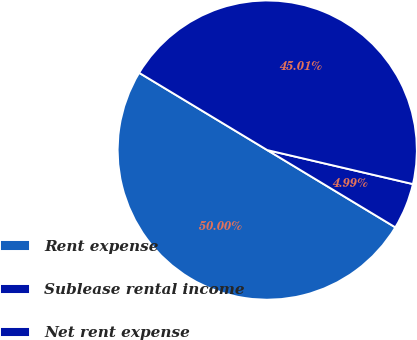<chart> <loc_0><loc_0><loc_500><loc_500><pie_chart><fcel>Rent expense<fcel>Sublease rental income<fcel>Net rent expense<nl><fcel>50.0%<fcel>4.99%<fcel>45.01%<nl></chart> 